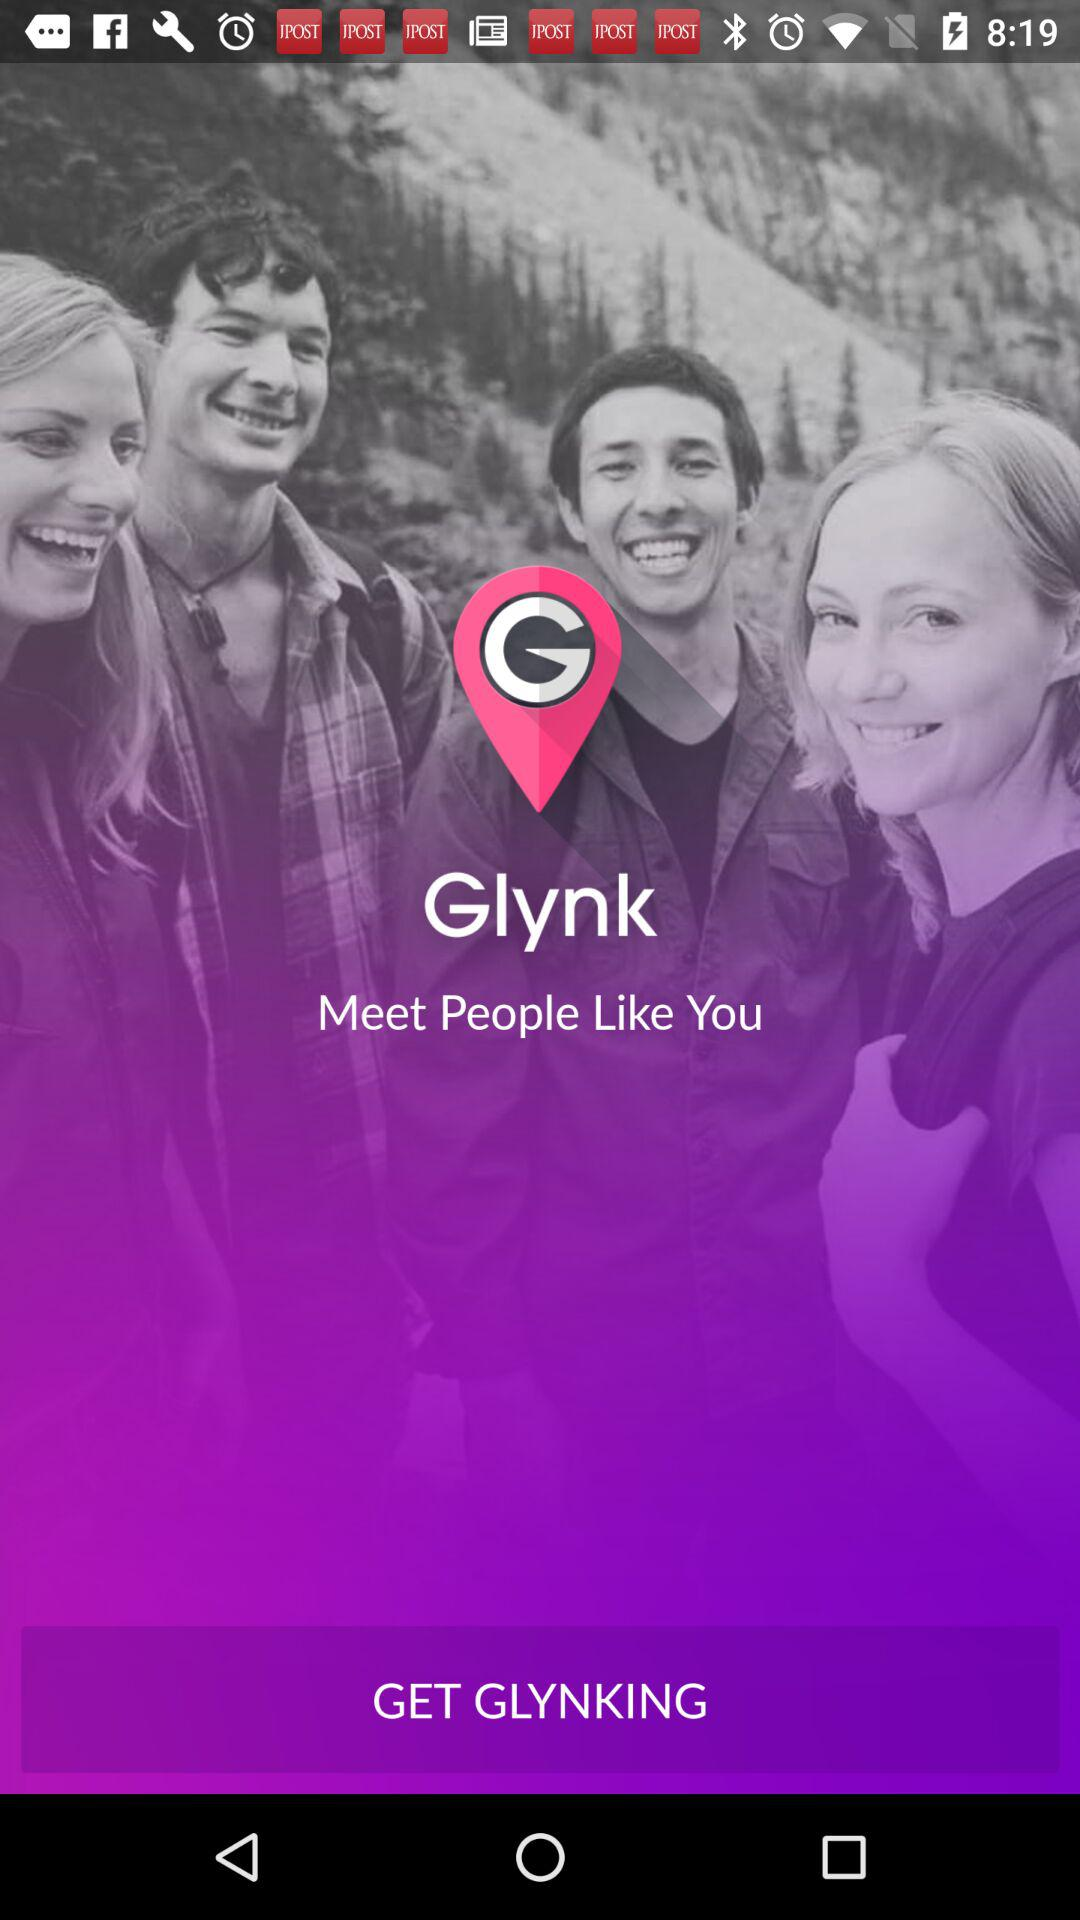What is the application name? The application name is "Glynk". 